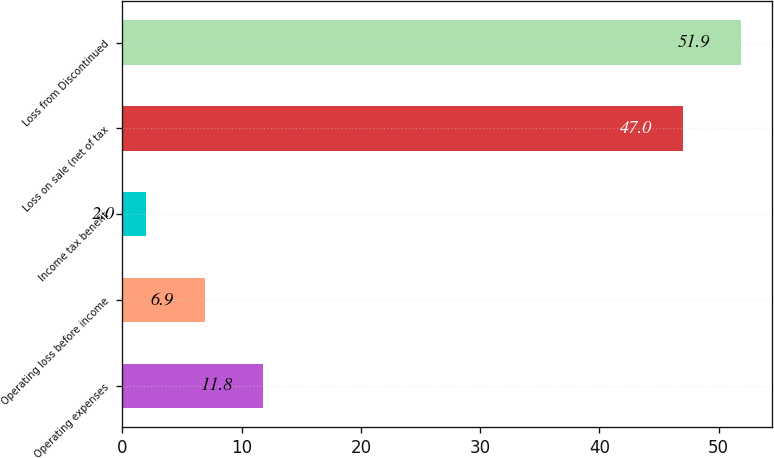Convert chart to OTSL. <chart><loc_0><loc_0><loc_500><loc_500><bar_chart><fcel>Operating expenses<fcel>Operating loss before income<fcel>Income tax benefit<fcel>Loss on sale (net of tax<fcel>Loss from Discontinued<nl><fcel>11.8<fcel>6.9<fcel>2<fcel>47<fcel>51.9<nl></chart> 